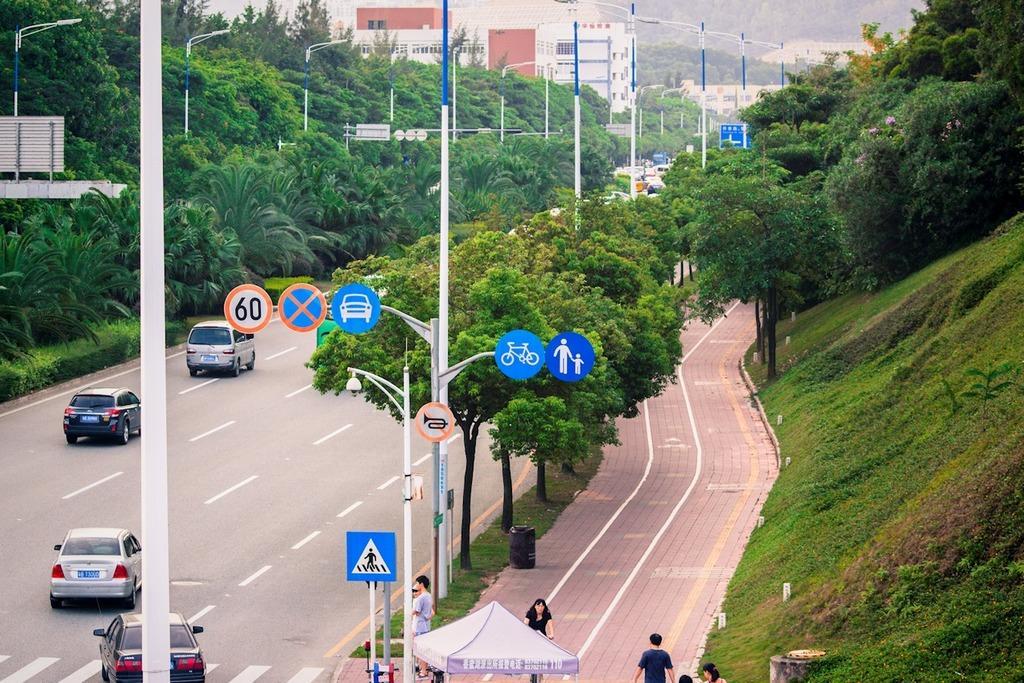In one or two sentences, can you explain what this image depicts? In this picture I can see the road, on which there are few cars and I can see the footpath on which there are few people and in the middle of this picture I can see number of light poles and I can see few sign boards and I can see number of trees. In the background I can see the buildings. On the right side of this picture I can see the grass and on the left side of this picture I can see few plants. 